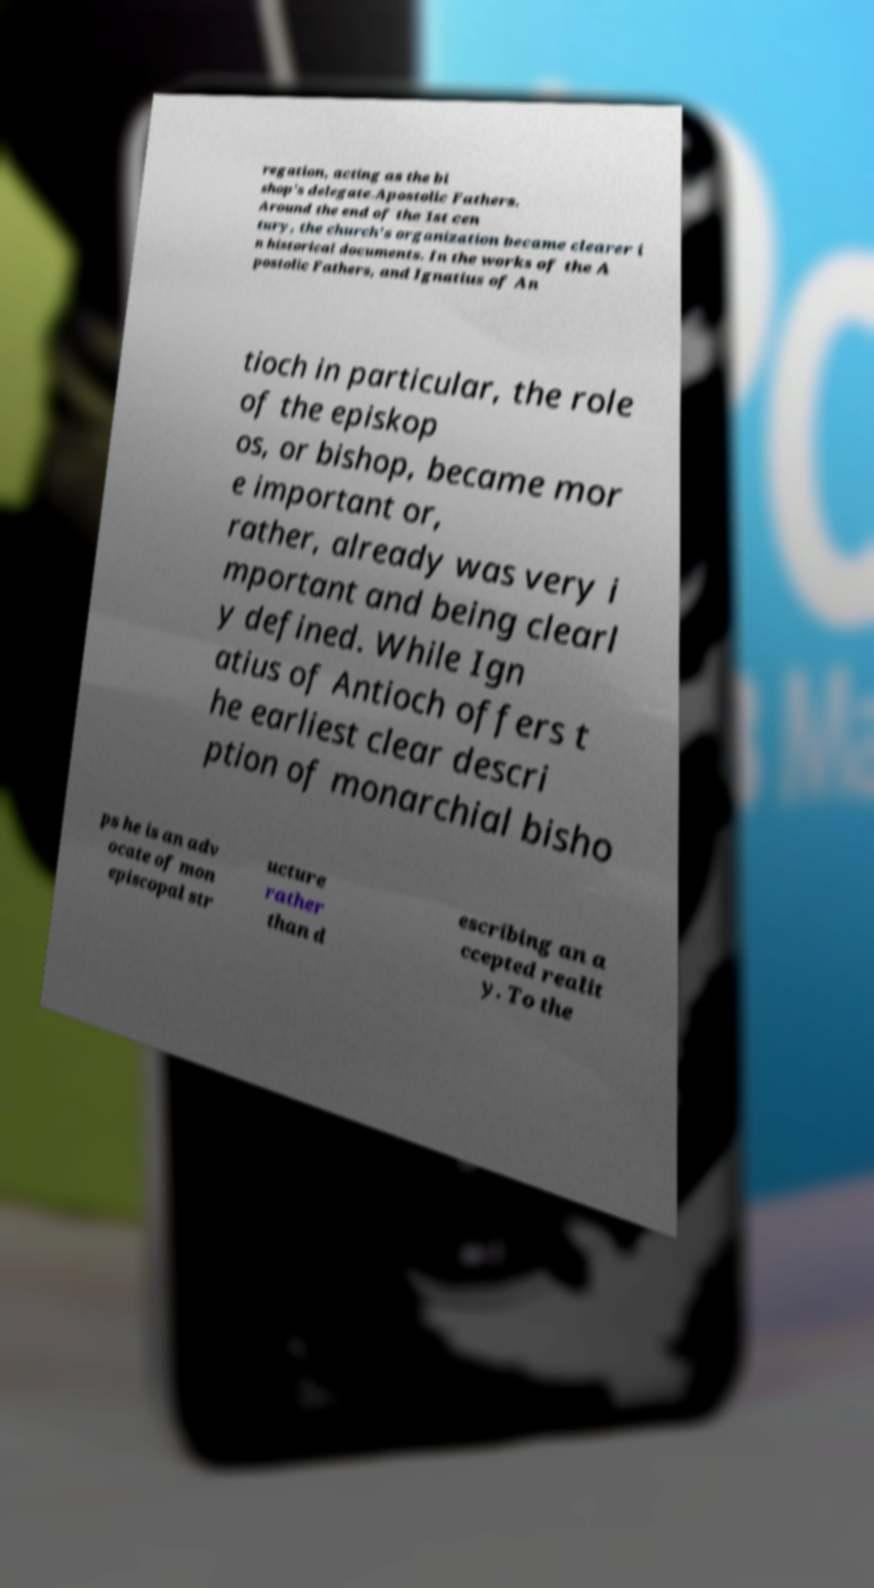Please read and relay the text visible in this image. What does it say? regation, acting as the bi shop's delegate.Apostolic Fathers. Around the end of the 1st cen tury, the church's organization became clearer i n historical documents. In the works of the A postolic Fathers, and Ignatius of An tioch in particular, the role of the episkop os, or bishop, became mor e important or, rather, already was very i mportant and being clearl y defined. While Ign atius of Antioch offers t he earliest clear descri ption of monarchial bisho ps he is an adv ocate of mon episcopal str ucture rather than d escribing an a ccepted realit y. To the 